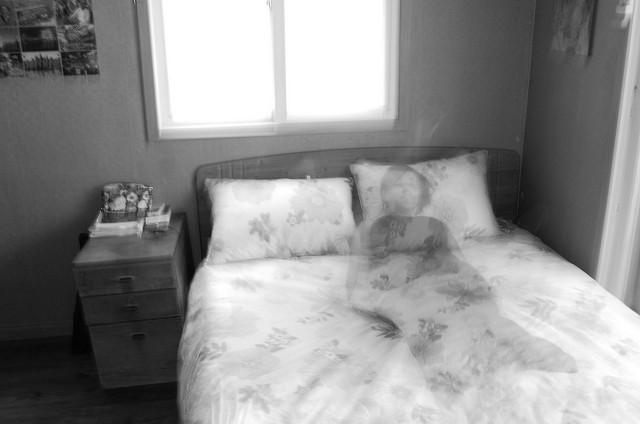The exposure makes the woman look like what?

Choices:
A) leprechaun
B) ghost
C) witch
D) vampire ghost 